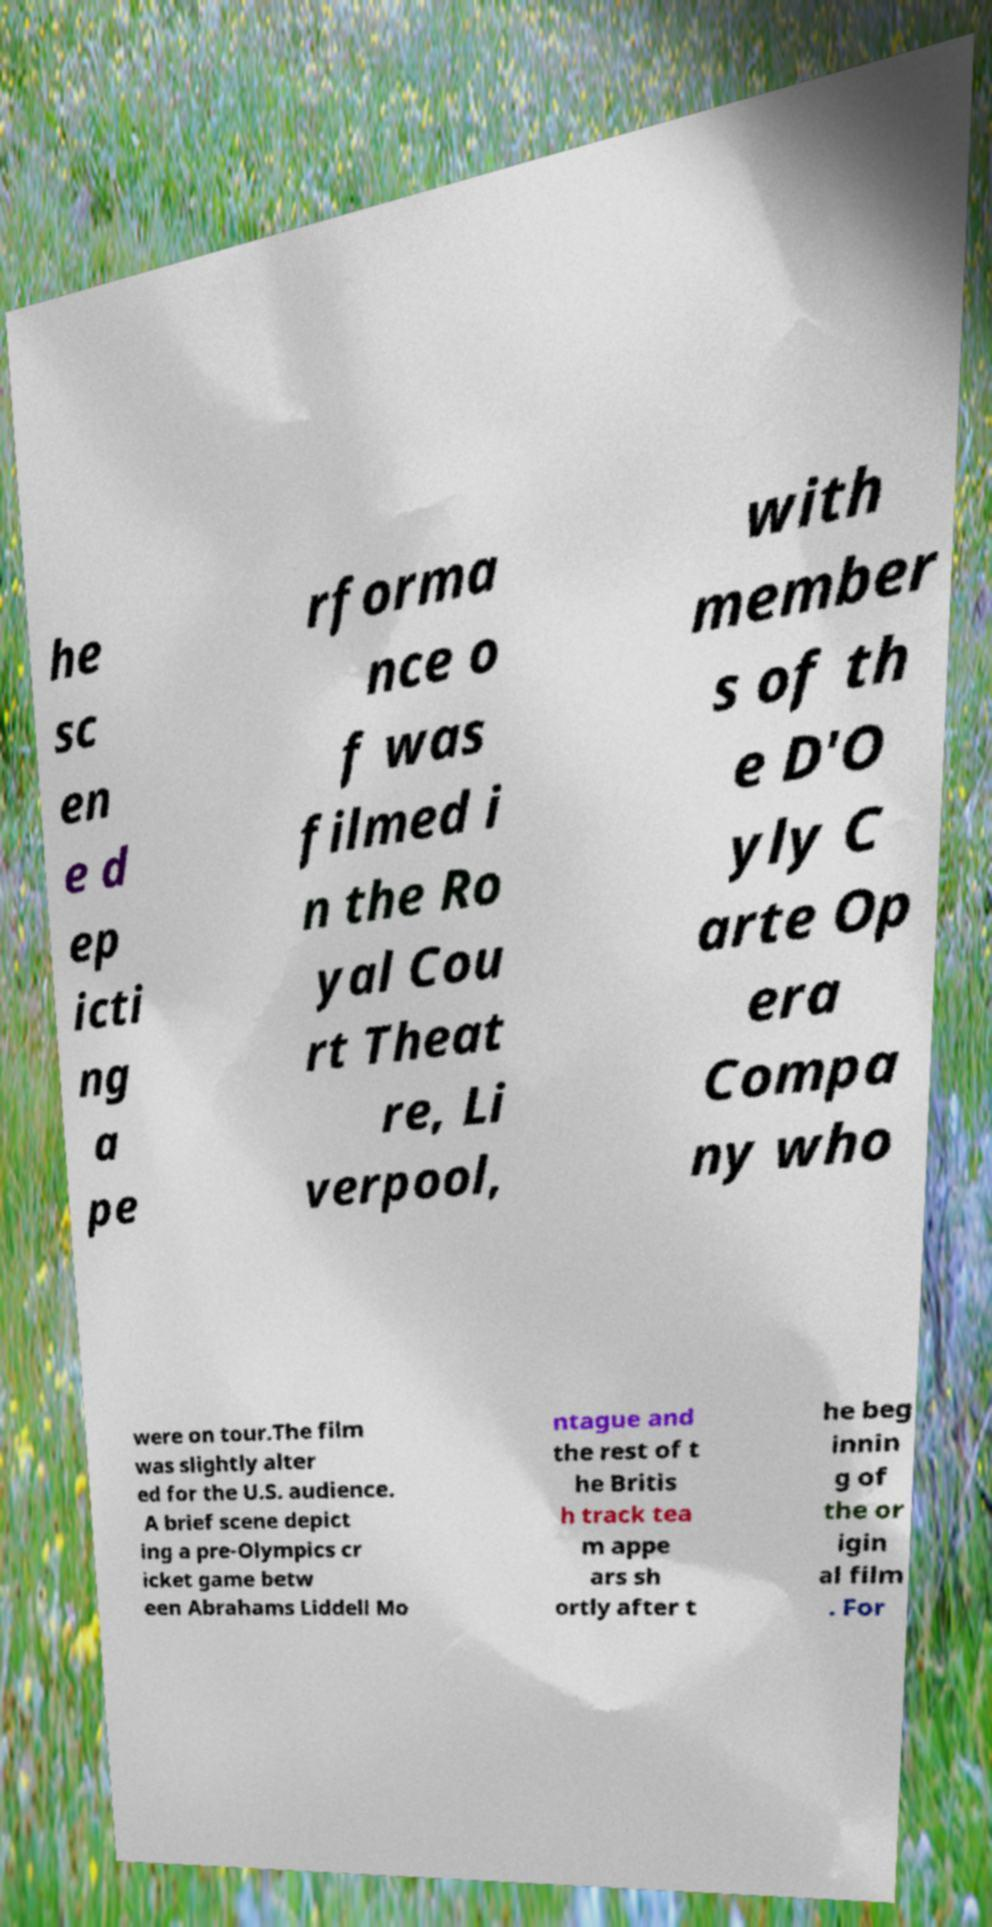Please identify and transcribe the text found in this image. he sc en e d ep icti ng a pe rforma nce o f was filmed i n the Ro yal Cou rt Theat re, Li verpool, with member s of th e D'O yly C arte Op era Compa ny who were on tour.The film was slightly alter ed for the U.S. audience. A brief scene depict ing a pre-Olympics cr icket game betw een Abrahams Liddell Mo ntague and the rest of t he Britis h track tea m appe ars sh ortly after t he beg innin g of the or igin al film . For 